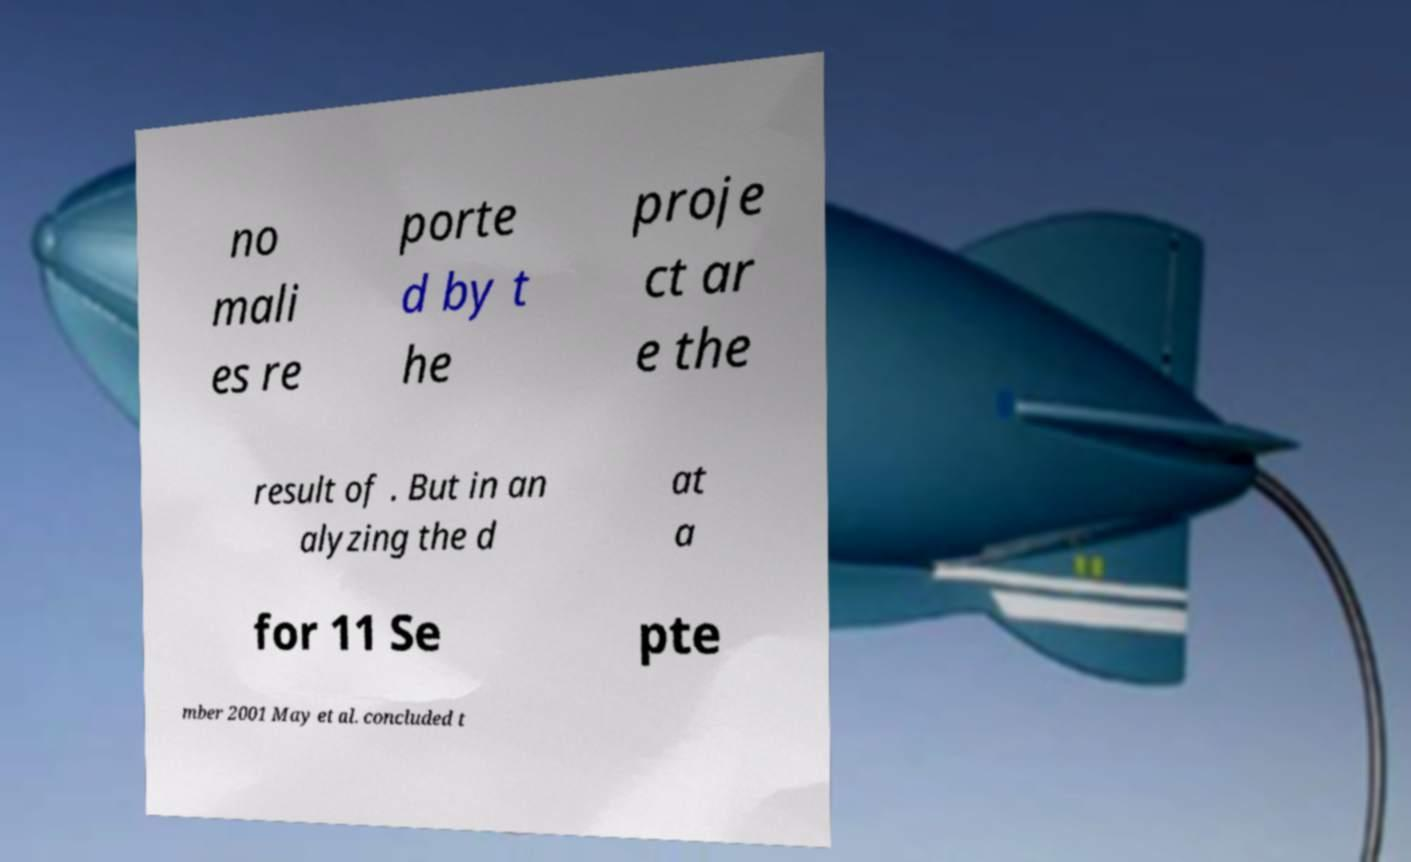Please read and relay the text visible in this image. What does it say? no mali es re porte d by t he proje ct ar e the result of . But in an alyzing the d at a for 11 Se pte mber 2001 May et al. concluded t 